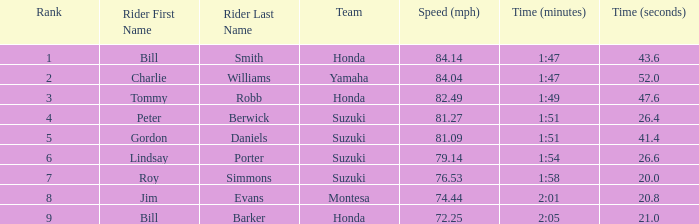6? Lindsay Porter. 